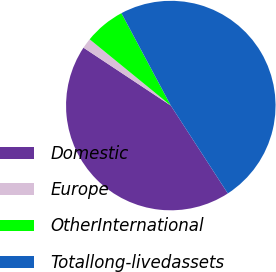Convert chart to OTSL. <chart><loc_0><loc_0><loc_500><loc_500><pie_chart><fcel>Domestic<fcel>Europe<fcel>OtherInternational<fcel>Totallong-livedassets<nl><fcel>43.48%<fcel>1.58%<fcel>6.29%<fcel>48.65%<nl></chart> 